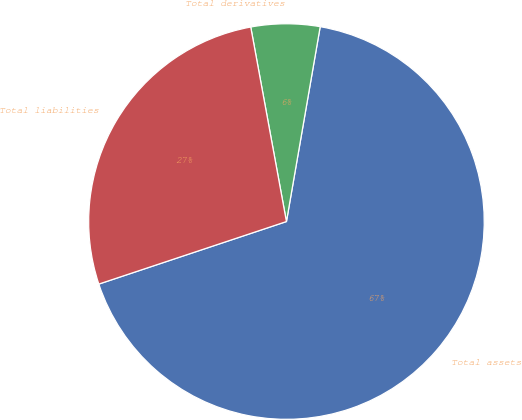Convert chart. <chart><loc_0><loc_0><loc_500><loc_500><pie_chart><fcel>Total assets<fcel>Total derivatives<fcel>Total liabilities<nl><fcel>67.15%<fcel>5.62%<fcel>27.23%<nl></chart> 